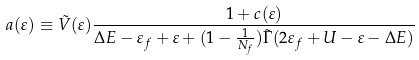Convert formula to latex. <formula><loc_0><loc_0><loc_500><loc_500>a ( \varepsilon ) \equiv \tilde { V } ( \varepsilon ) \frac { 1 + c ( \varepsilon ) } { \Delta E - \varepsilon _ { f } + \varepsilon + ( 1 - \frac { 1 } { N _ { f } } ) \tilde { \Gamma } ( 2 \varepsilon _ { f } + U - \varepsilon - \Delta E ) }</formula> 